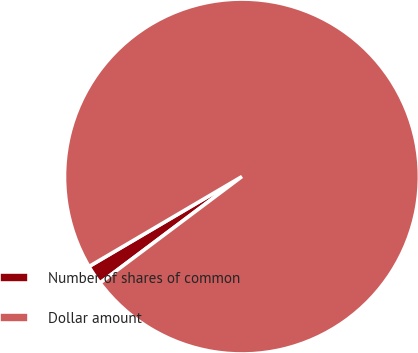<chart> <loc_0><loc_0><loc_500><loc_500><pie_chart><fcel>Number of shares of common<fcel>Dollar amount<nl><fcel>1.78%<fcel>98.22%<nl></chart> 